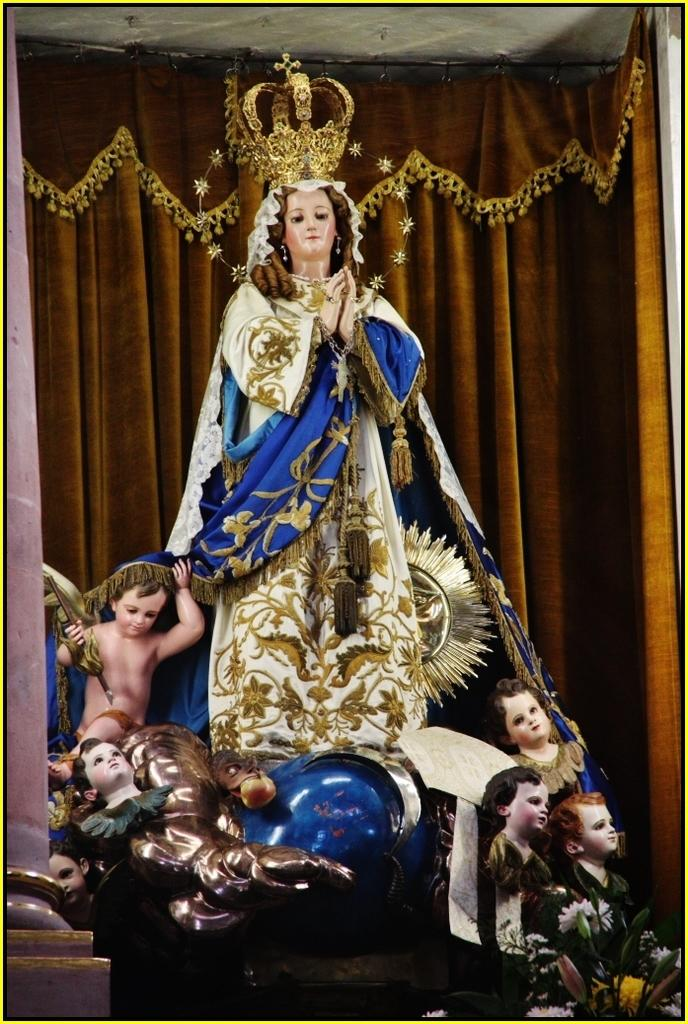What can be seen in the image? There are idols in the image. What is present in the background of the image? There is a curtain and the roof visible in the background of the image. What system is being used to control the idols' movements in the image? There is no indication in the image that the idols are moving or that any system is being used to control their movements. 